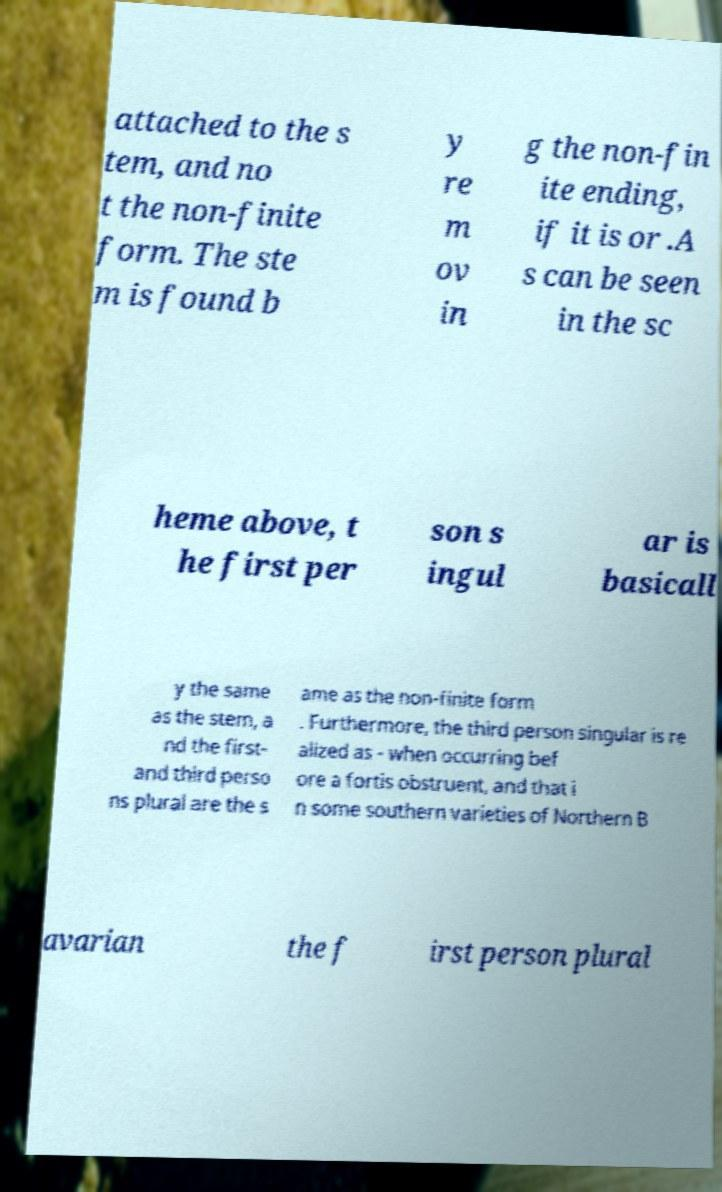For documentation purposes, I need the text within this image transcribed. Could you provide that? attached to the s tem, and no t the non-finite form. The ste m is found b y re m ov in g the non-fin ite ending, if it is or .A s can be seen in the sc heme above, t he first per son s ingul ar is basicall y the same as the stem, a nd the first- and third perso ns plural are the s ame as the non-finite form . Furthermore, the third person singular is re alized as - when occurring bef ore a fortis obstruent, and that i n some southern varieties of Northern B avarian the f irst person plural 